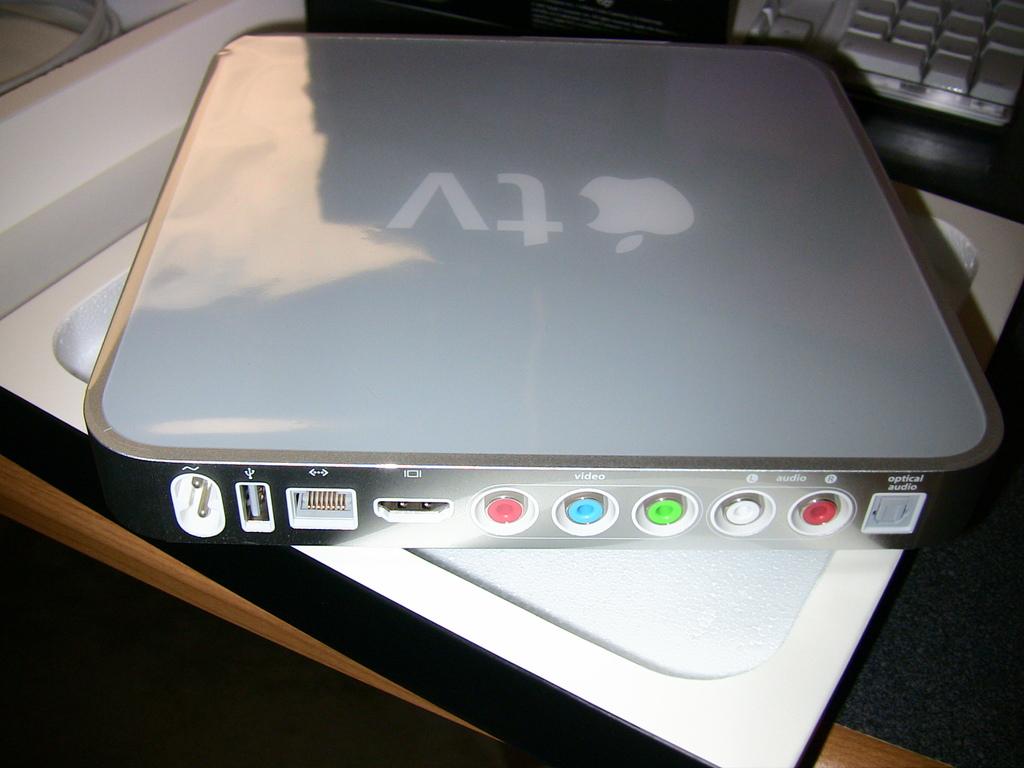What kind of device is this?
Give a very brief answer. Apple tv. Is this an apple product?
Provide a short and direct response. Yes. 